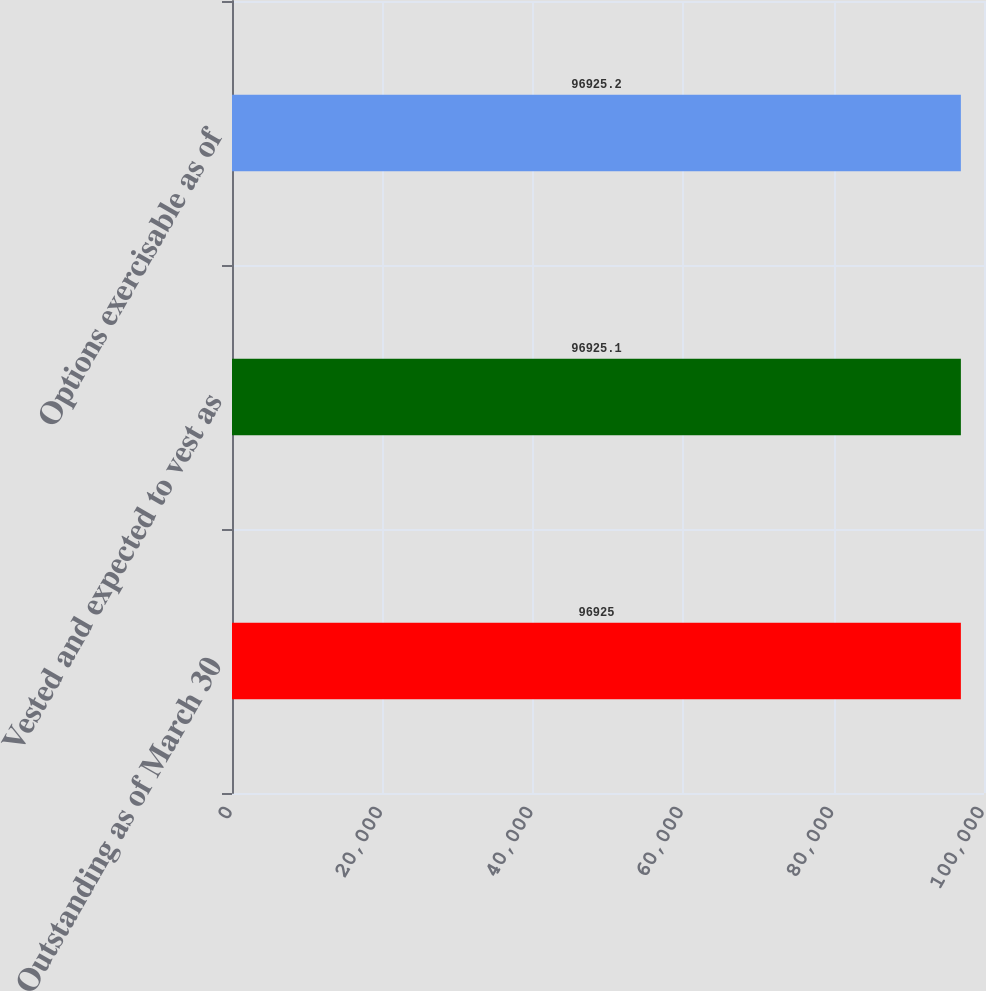Convert chart. <chart><loc_0><loc_0><loc_500><loc_500><bar_chart><fcel>Outstanding as of March 30<fcel>Vested and expected to vest as<fcel>Options exercisable as of<nl><fcel>96925<fcel>96925.1<fcel>96925.2<nl></chart> 